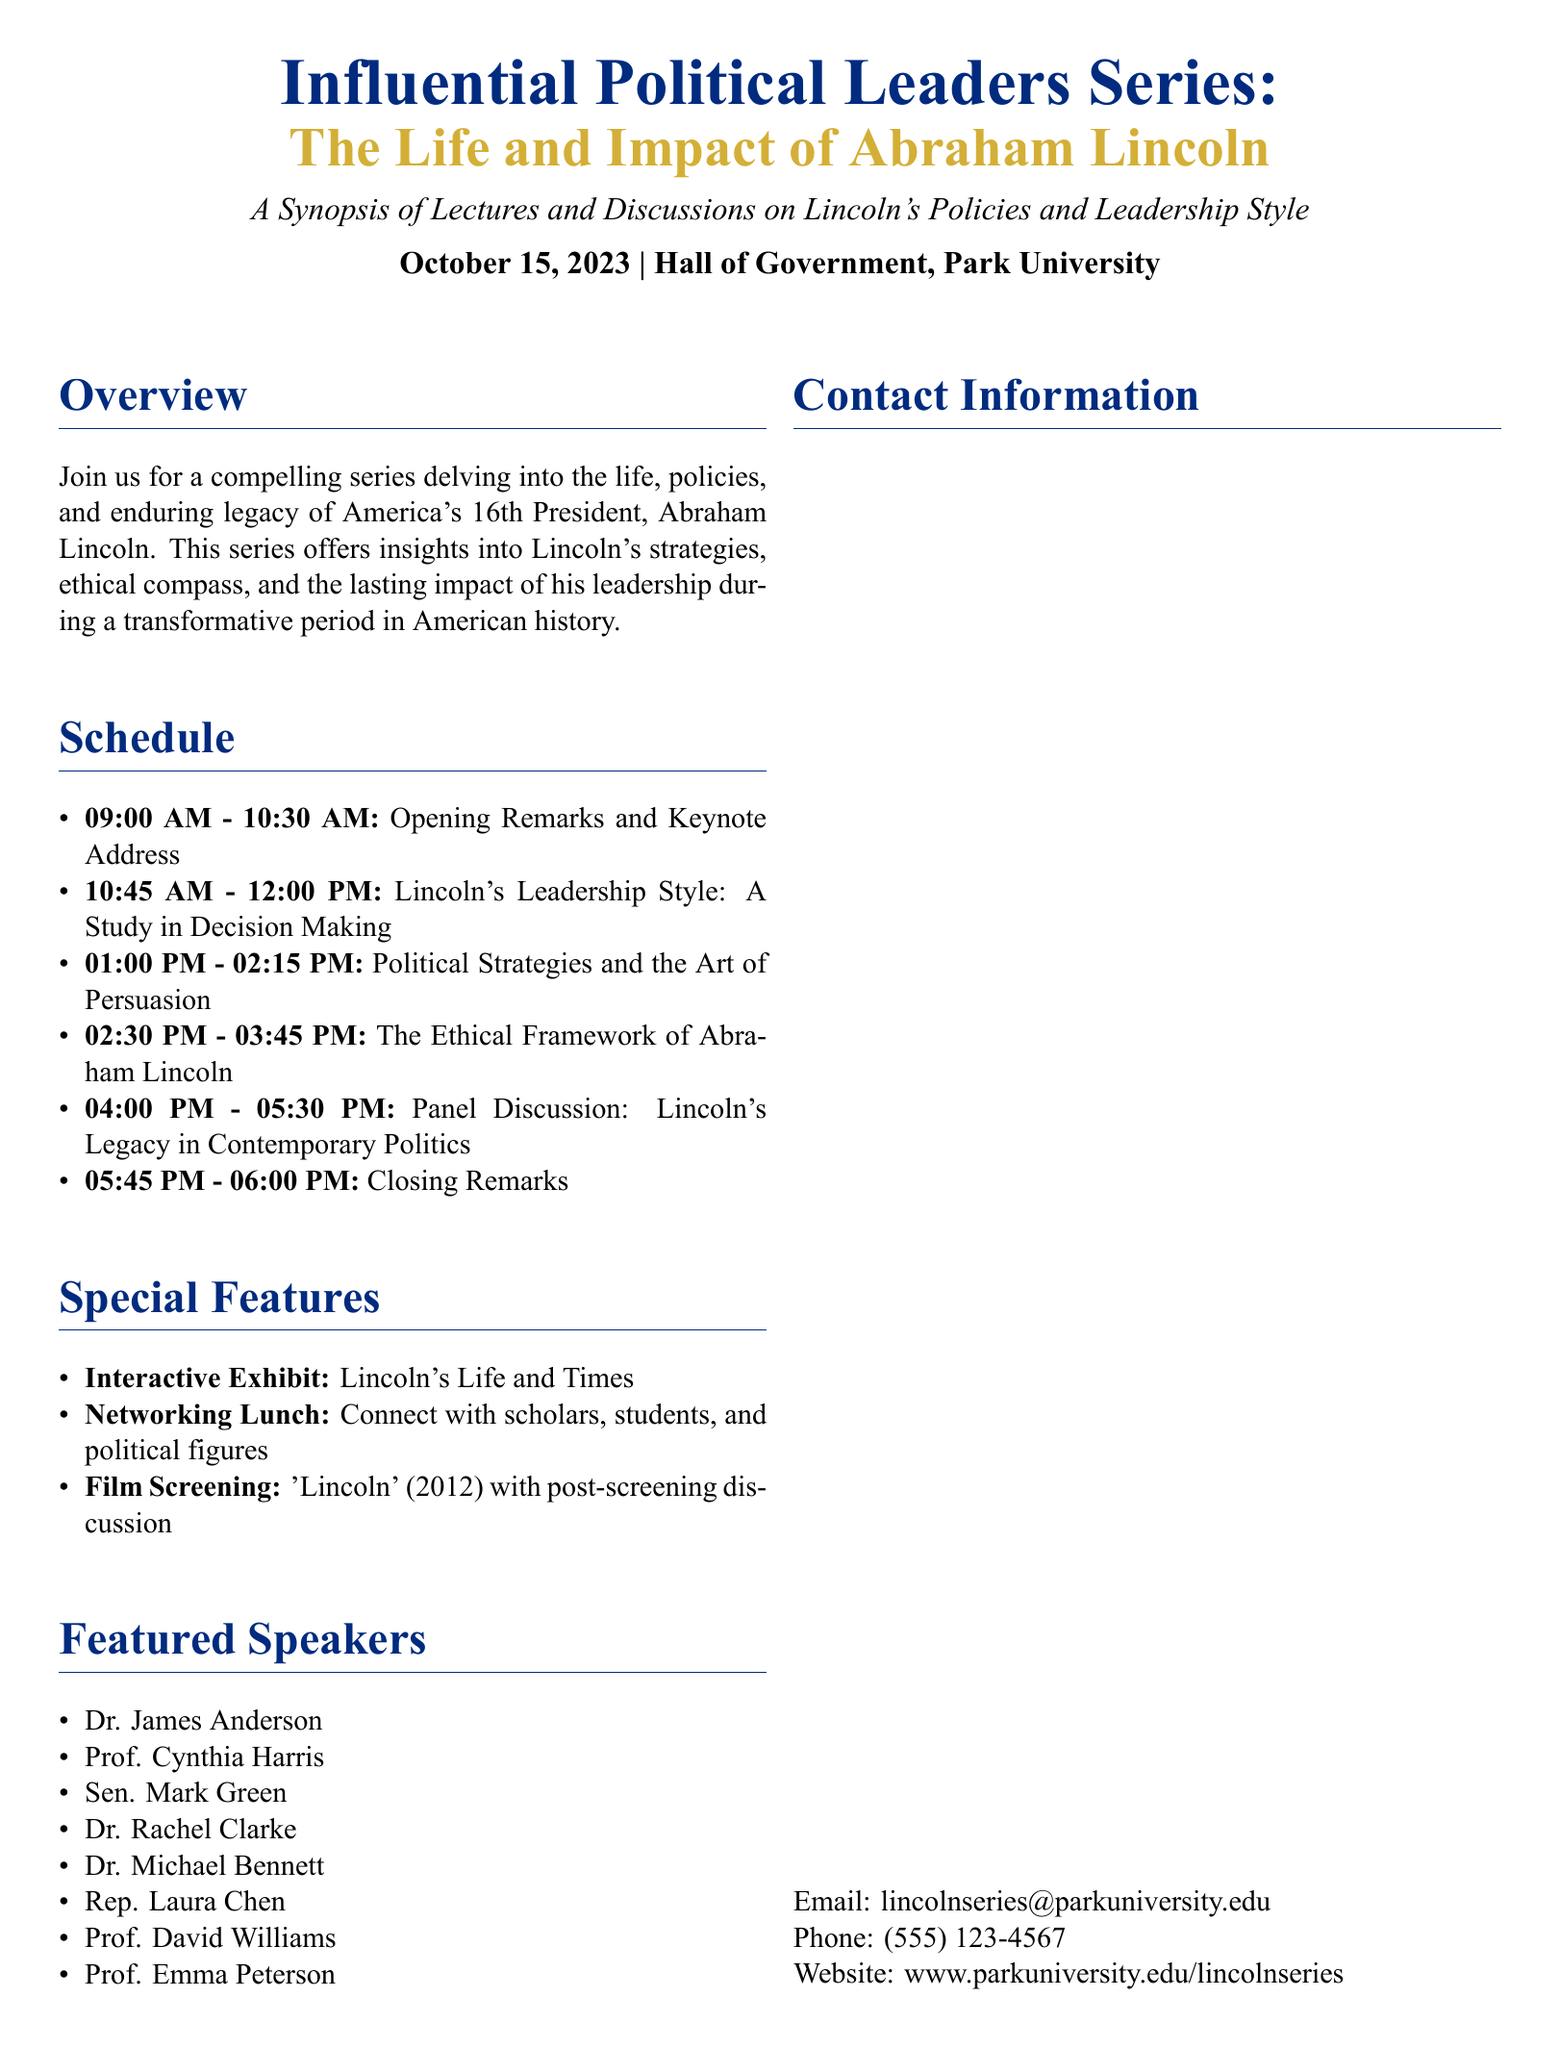What is the date of the event? The date of the event is specified as October 15, 2023, in the document.
Answer: October 15, 2023 What is one of the featured speakers' names? The document lists several featured speakers, one of them being Dr. James Anderson.
Answer: Dr. James Anderson What is the time for the panel discussion? The panel discussion is scheduled for 04:00 PM to 05:30 PM, as indicated in the schedule section.
Answer: 04:00 PM - 05:30 PM Which film will be screened during the event? The film screening mentioned in the document is for 'Lincoln' (2012).
Answer: 'Lincoln' (2012) What is the purpose of the Networking Lunch? The document states the Networking Lunch allows attendees to connect with scholars, students, and political figures, which implies its purpose.
Answer: Connect with scholars, students, and political figures What is the theme of the keynote address? The keynote address is part of the opening remarks and will focus on Lincoln's life and impact, reflecting the overall theme of the series.
Answer: Lincoln's life and impact How long is the session on Lincoln's Leadership Style? The session on Lincoln's Leadership Style is scheduled for 10:45 AM to 12:00 PM, which makes it 1 hour and 15 minutes long.
Answer: 1 hour and 15 minutes What does the quote by Abraham Lincoln say? The quote included in the document is "A house divided against itself cannot stand."
Answer: "A house divided against itself cannot stand." What is the color theme used in the document? The colors lincolnblue and lincolngold are prominently featured in the document, indicating a cohesive theme.
Answer: lincolnblue and lincolngold 